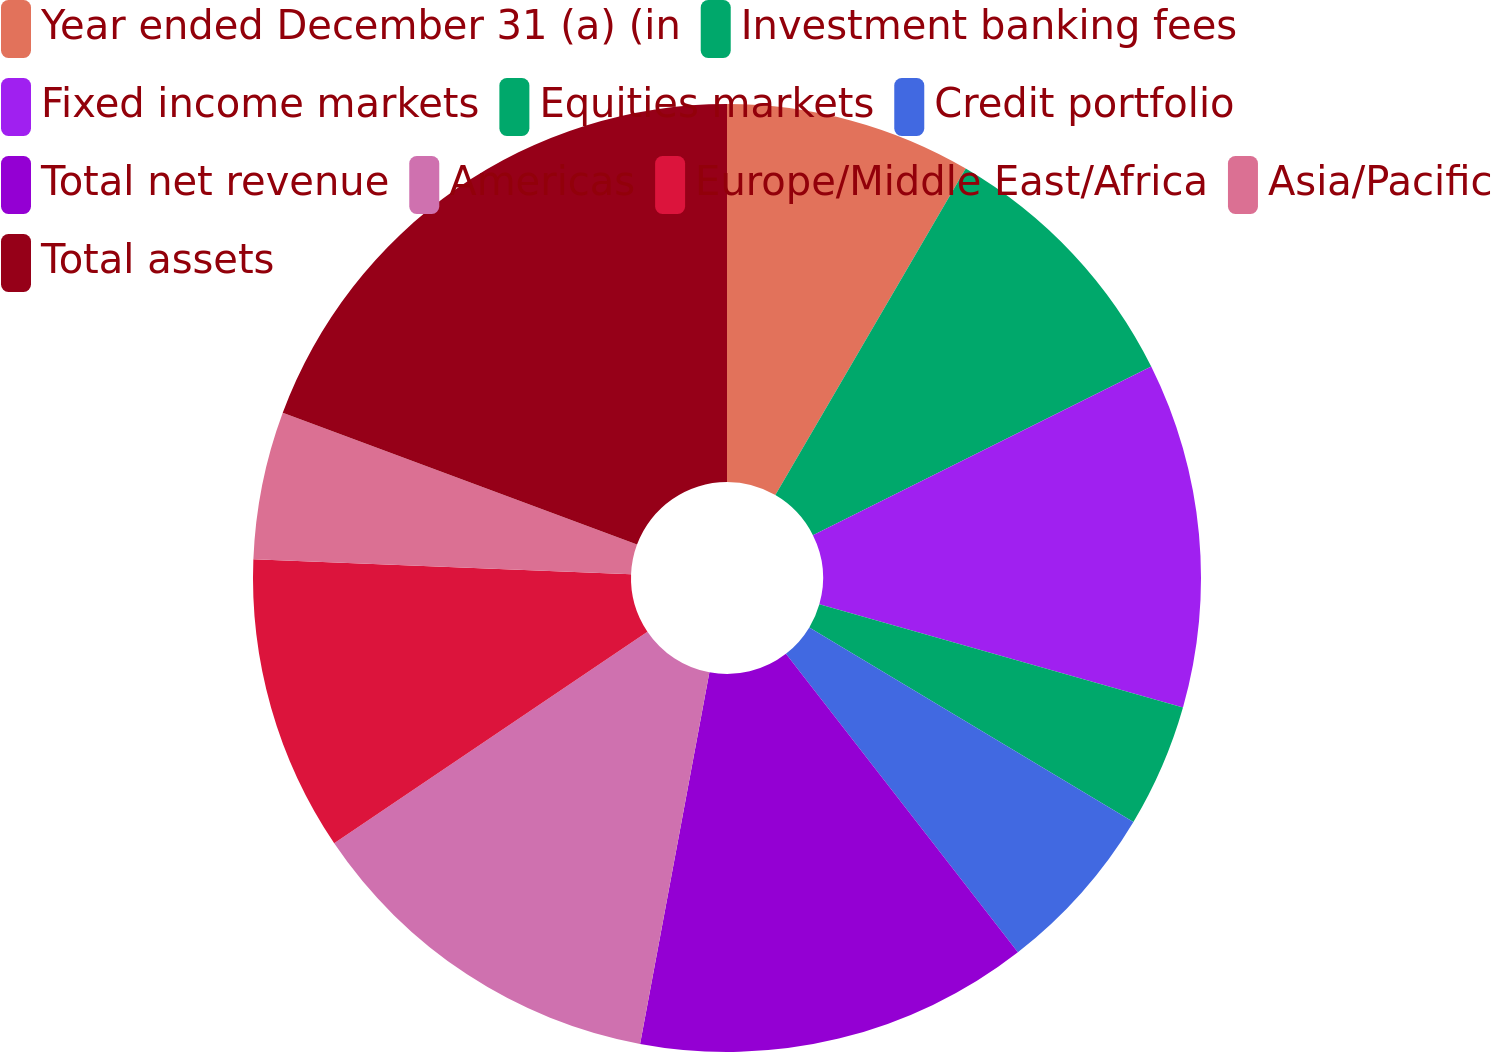Convert chart. <chart><loc_0><loc_0><loc_500><loc_500><pie_chart><fcel>Year ended December 31 (a) (in<fcel>Investment banking fees<fcel>Fixed income markets<fcel>Equities markets<fcel>Credit portfolio<fcel>Total net revenue<fcel>Americas<fcel>Europe/Middle East/Africa<fcel>Asia/Pacific<fcel>Total assets<nl><fcel>8.4%<fcel>9.24%<fcel>11.76%<fcel>4.2%<fcel>5.88%<fcel>13.45%<fcel>12.61%<fcel>10.08%<fcel>5.04%<fcel>19.33%<nl></chart> 